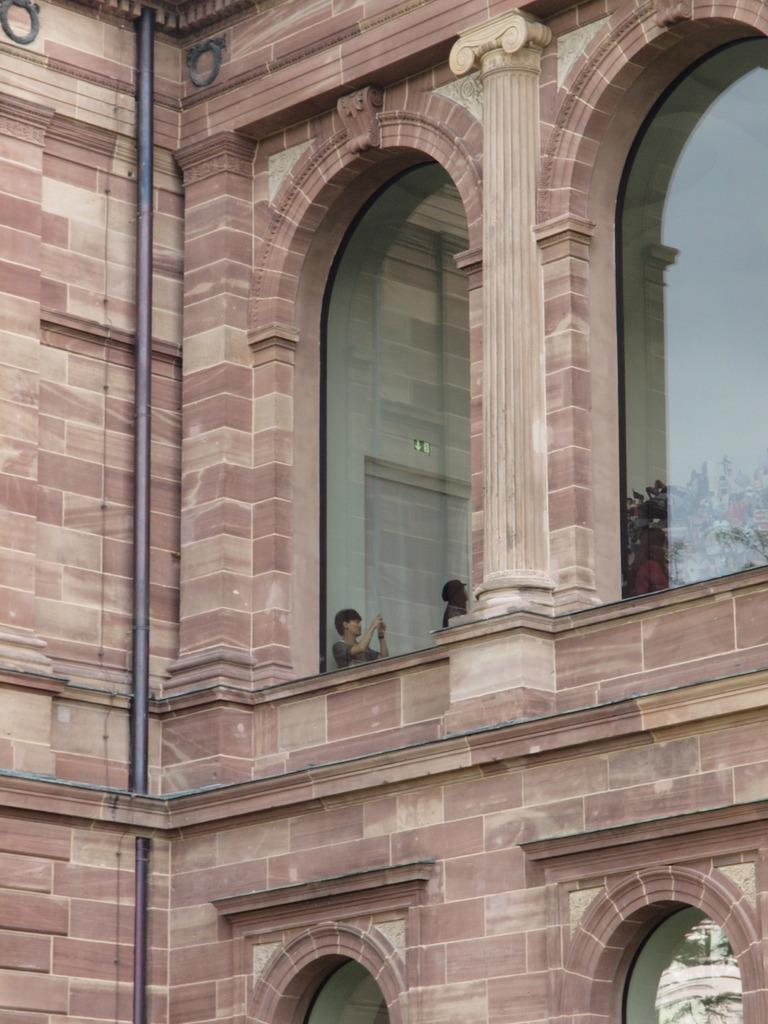What type of structure is visible in the image? There is a building in the image. Can you describe any specific features of the building? There is a pipe and glass visible in the image, which may be part of the building. What type of material is used for the walls in the image? There are walls in the image, but the material is not specified. What type of vegetation is present in the image? There are plants in the image. How many people are in the image? There are two people in the image. Can you describe the gender of one of the people? One of the people is a man. What is the man holding in the image? The man is holding an object with his hands. What type of prison can be seen in the background of the image? There is no prison present in the image; it features a building, plants, and people. How many brothers are visible in the image? There is no mention of a brother or any family relationship in the image. 